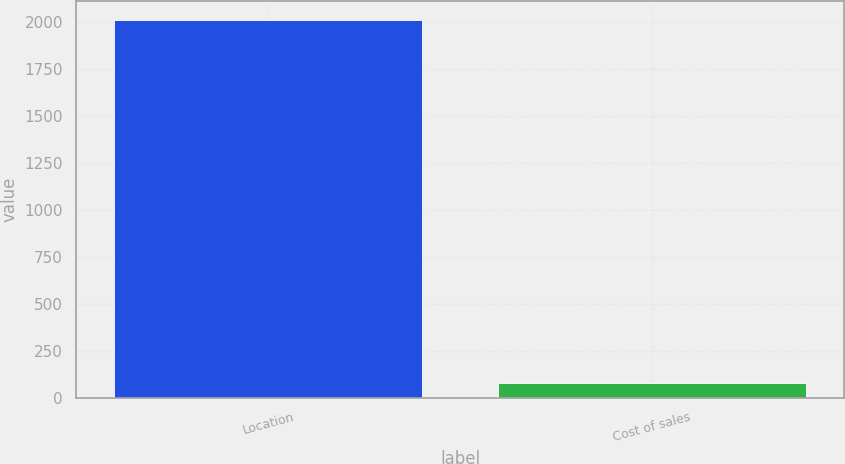Convert chart. <chart><loc_0><loc_0><loc_500><loc_500><bar_chart><fcel>Location<fcel>Cost of sales<nl><fcel>2011<fcel>77.3<nl></chart> 